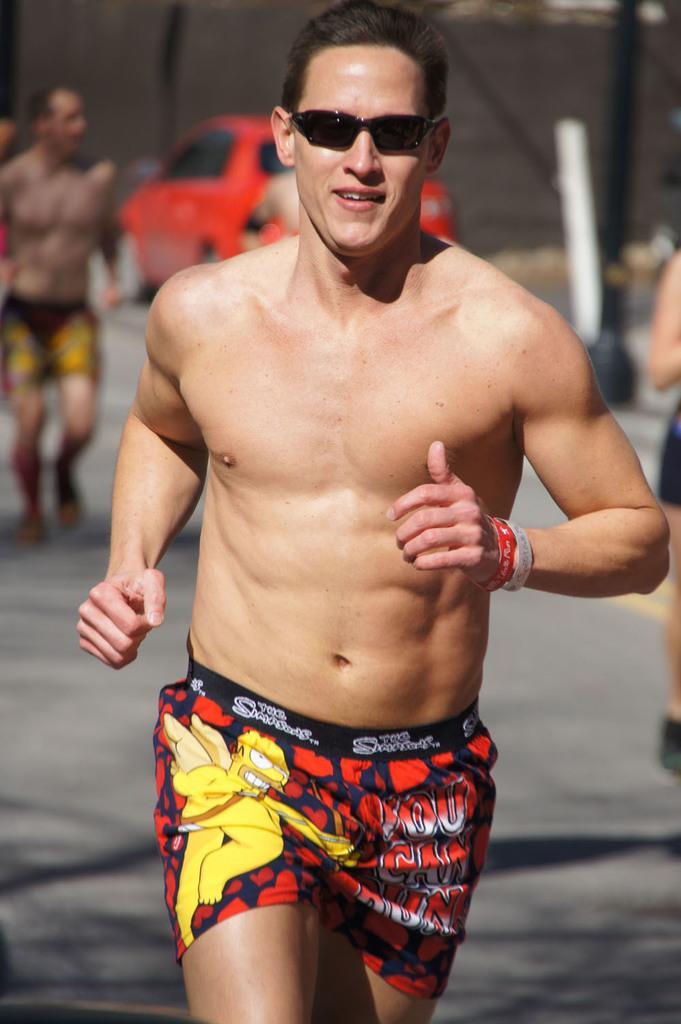Could you give a brief overview of what you see in this image? In this image we can see a man running. In the background there is a car and we can see people. There are poles. 